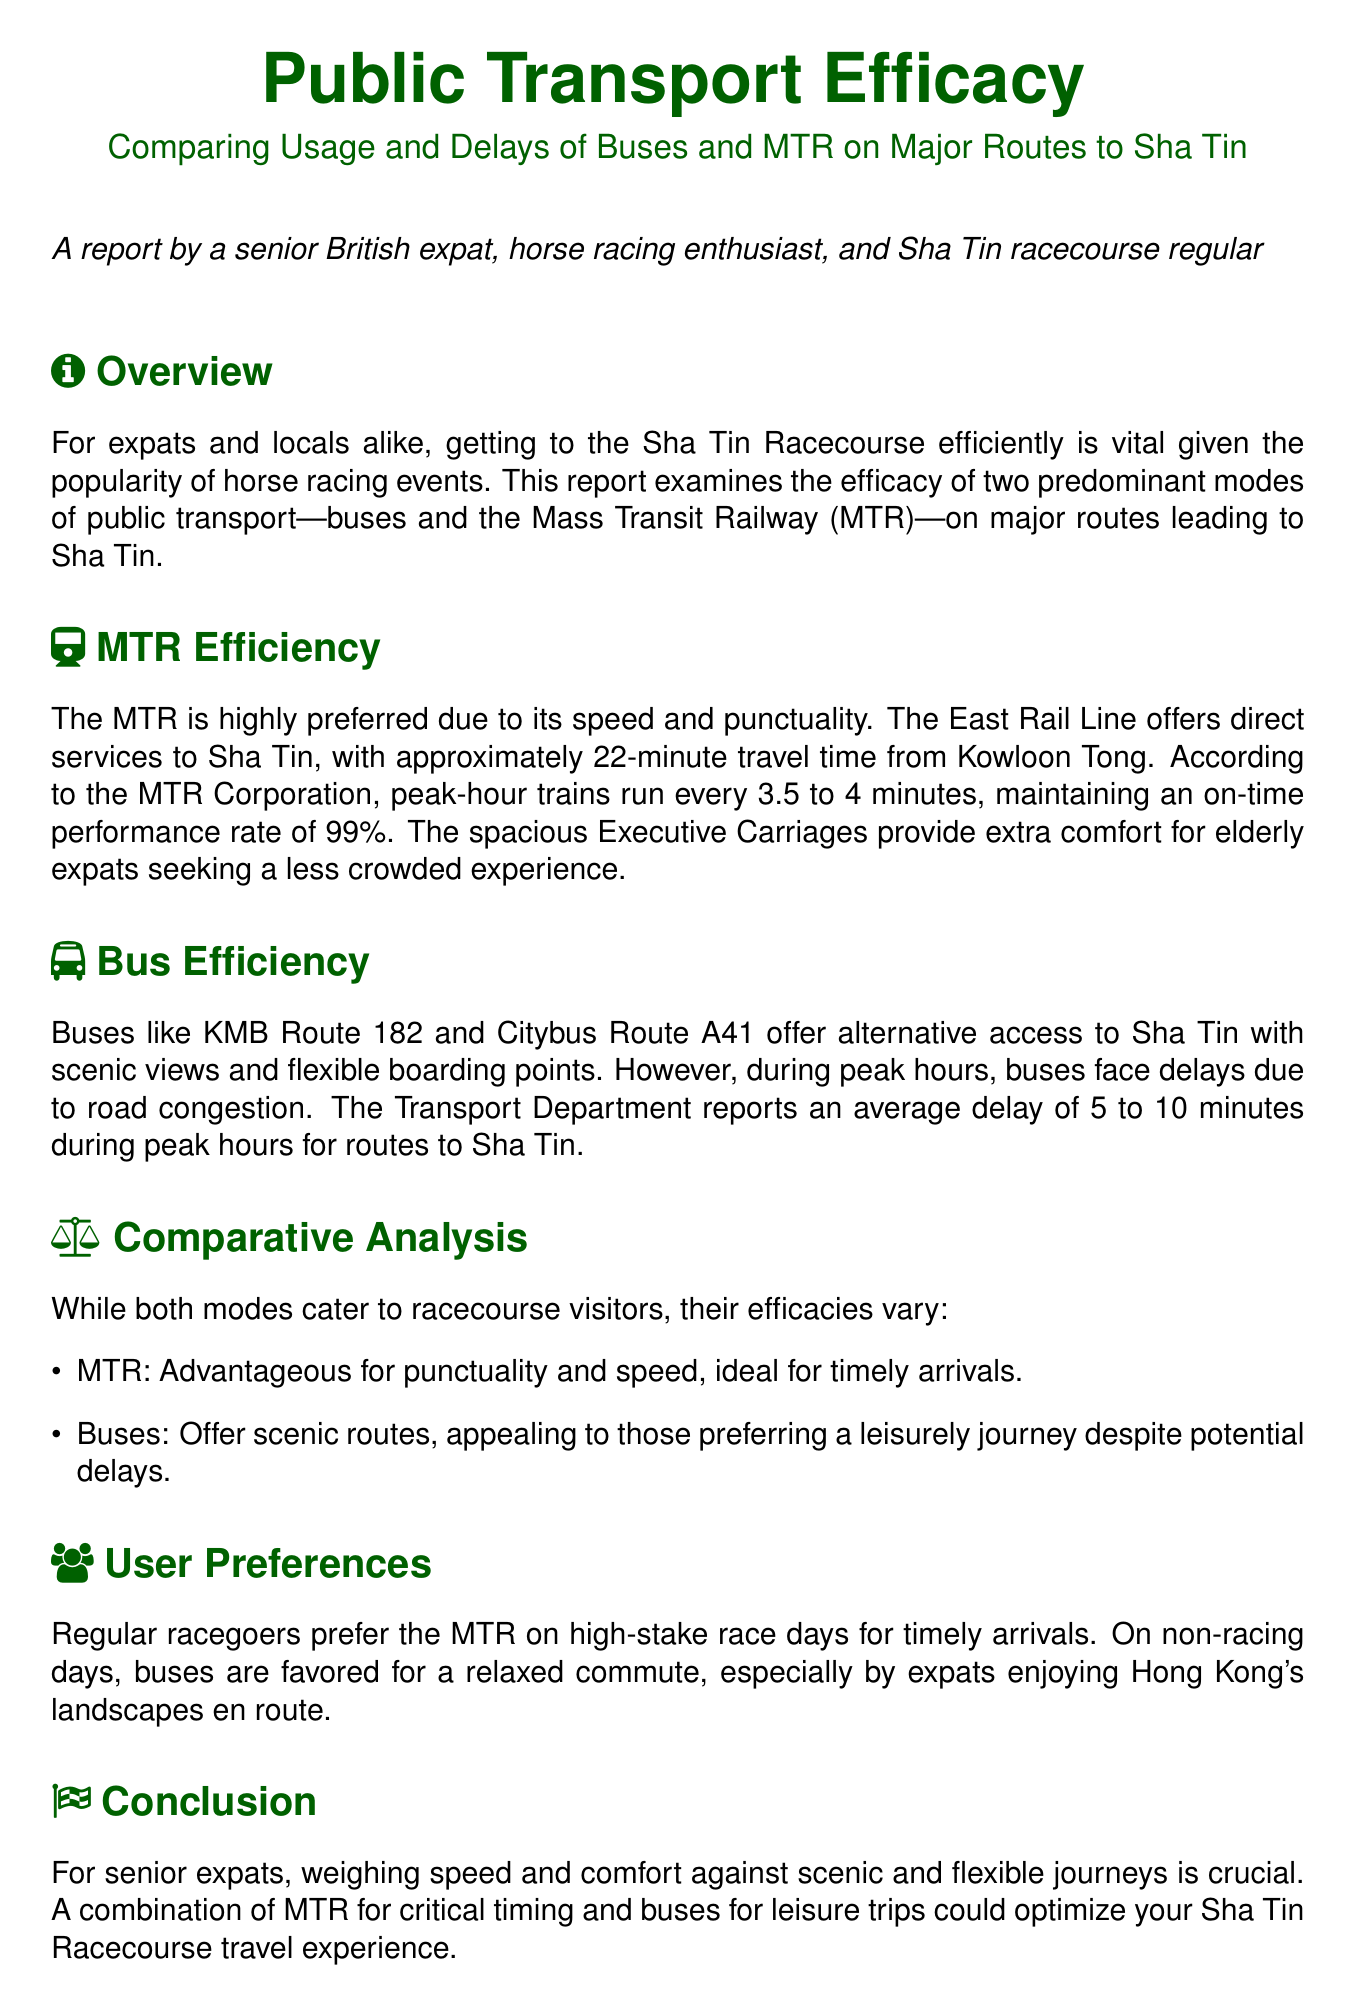What is the average travel time from Kowloon Tong to Sha Tin via MTR? The document states that the average travel time from Kowloon Tong to Sha Tin via MTR is 22 minutes.
Answer: 22 minutes How often do peak-hour trains run on the MTR? According to the document, peak-hour trains run every 3.5 to 4 minutes.
Answer: 3.5 to 4 minutes What is the on-time performance rate of the MTR? The document indicates an on-time performance rate of 99%.
Answer: 99% What is the average delay for buses during peak hours? The average delay for buses during peak hours is reported to be 5 to 10 minutes.
Answer: 5 to 10 minutes Which mode of transport do regular racegoers prefer on high-stake race days? The document mentions that regular racegoers prefer the MTR on high-stake race days for timely arrivals.
Answer: MTR What aspect of bus travel is appealing to expats on non-racing days? The document states that buses are favored for a relaxed commute on non-racing days.
Answer: Relaxed commute What two aspects should senior expats weigh when deciding on transport? The document advises senior expats to weigh speed and comfort against scenic and flexible journeys.
Answer: Speed and comfort What is a major disadvantage of buses according to the report? The report points out that buses face delays due to road congestion during peak hours.
Answer: Delays due to road congestion What combination of transport is suggested to optimize travel to Sha Tin? It is suggested to use a combination of MTR for critical timing and buses for leisure trips.
Answer: MTR and buses 